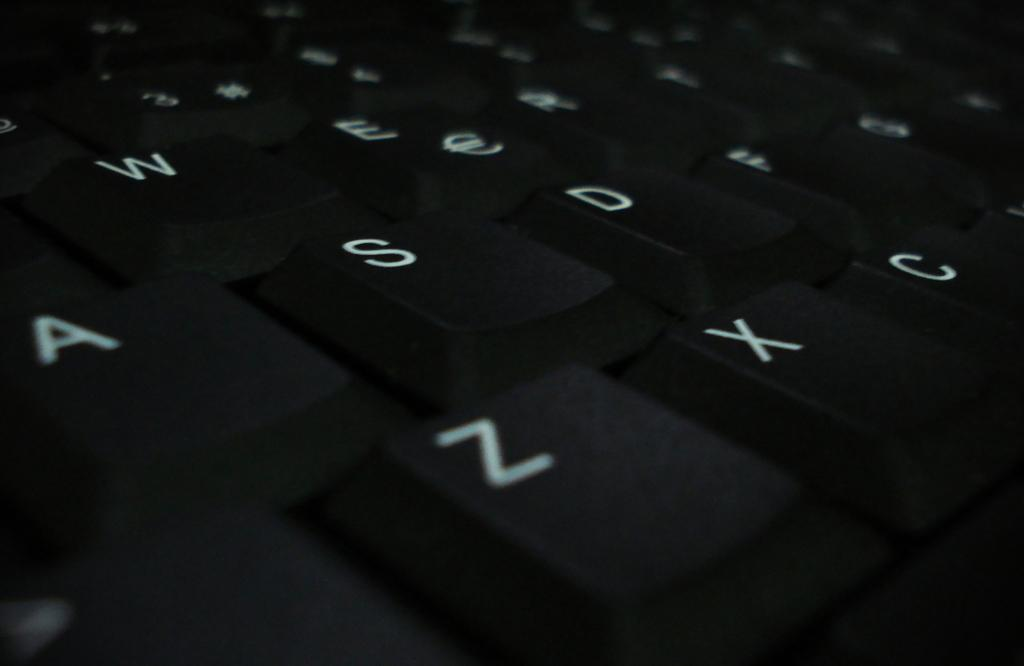Provide a one-sentence caption for the provided image. Black keyboard that has the X key between the Z and C key. 